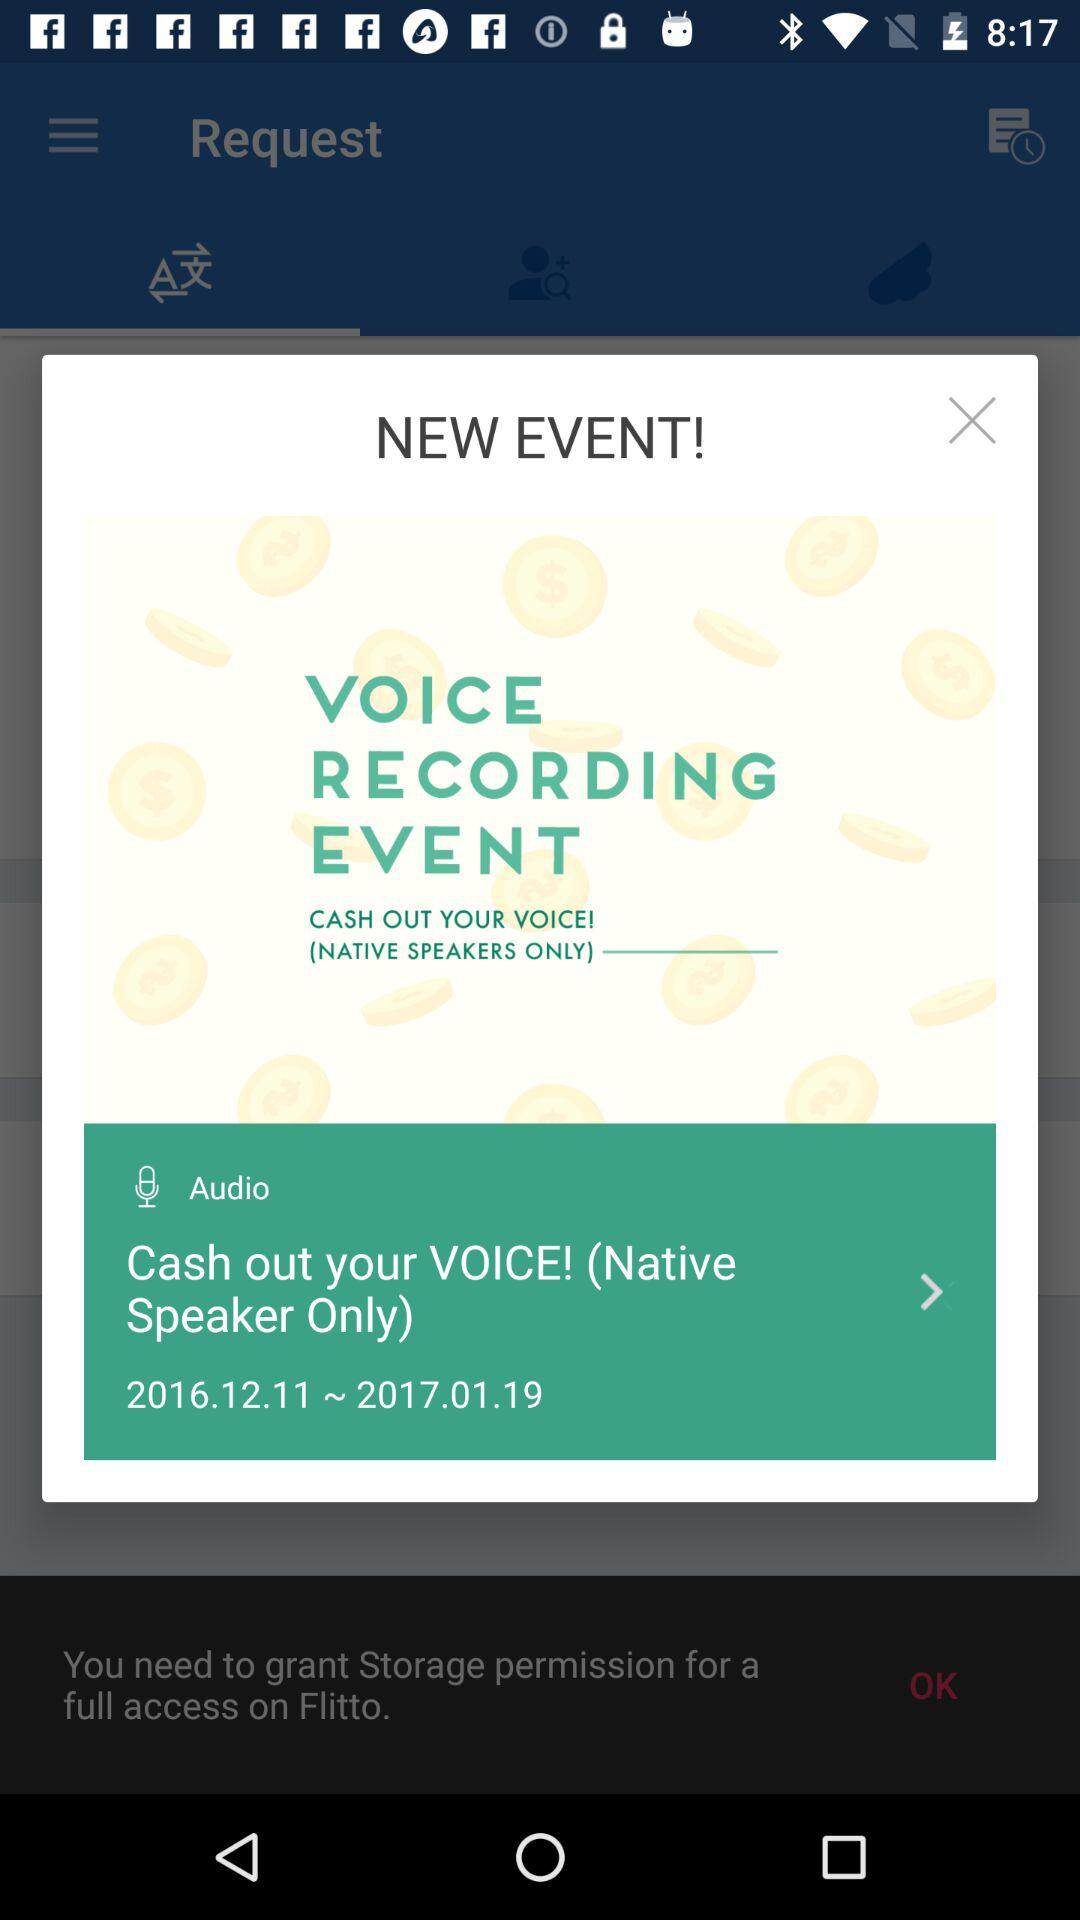What types of speakers are only allowed? There are only native speakers allowed. 